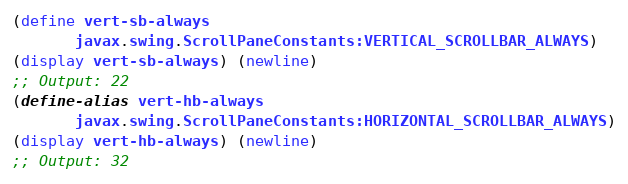Convert code to text. <code><loc_0><loc_0><loc_500><loc_500><_Scheme_>(define vert-sb-always
       javax.swing.ScrollPaneConstants:VERTICAL_SCROLLBAR_ALWAYS)
(display vert-sb-always) (newline)
;; Output: 22
(define-alias vert-hb-always
       javax.swing.ScrollPaneConstants:HORIZONTAL_SCROLLBAR_ALWAYS)
(display vert-hb-always) (newline)
;; Output: 32
</code> 